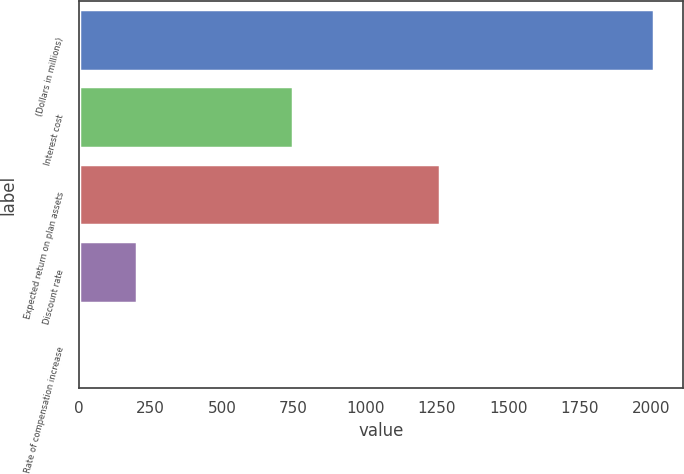Convert chart. <chart><loc_0><loc_0><loc_500><loc_500><bar_chart><fcel>(Dollars in millions)<fcel>Interest cost<fcel>Expected return on plan assets<fcel>Discount rate<fcel>Rate of compensation increase<nl><fcel>2010<fcel>748<fcel>1263<fcel>204.6<fcel>4<nl></chart> 